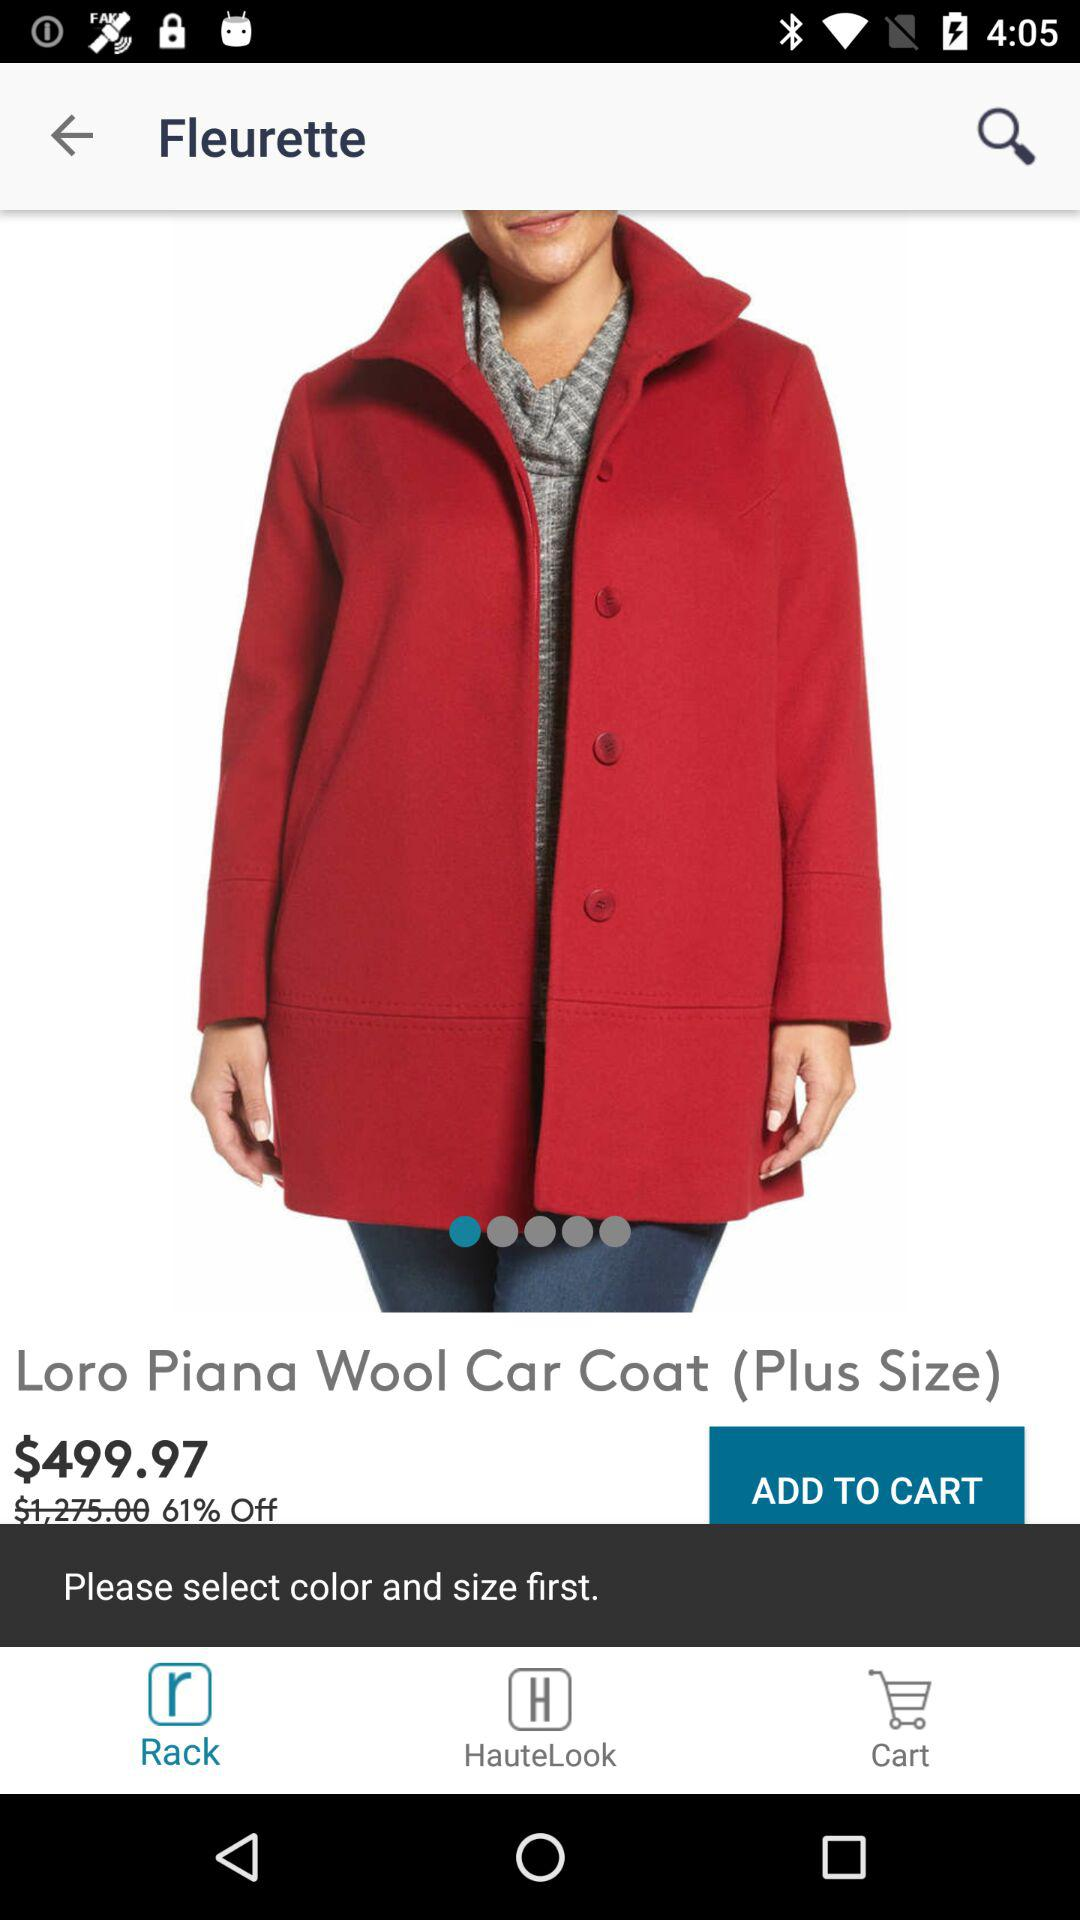How much of a discount is given on the item? The given discount on the item is 61%. 